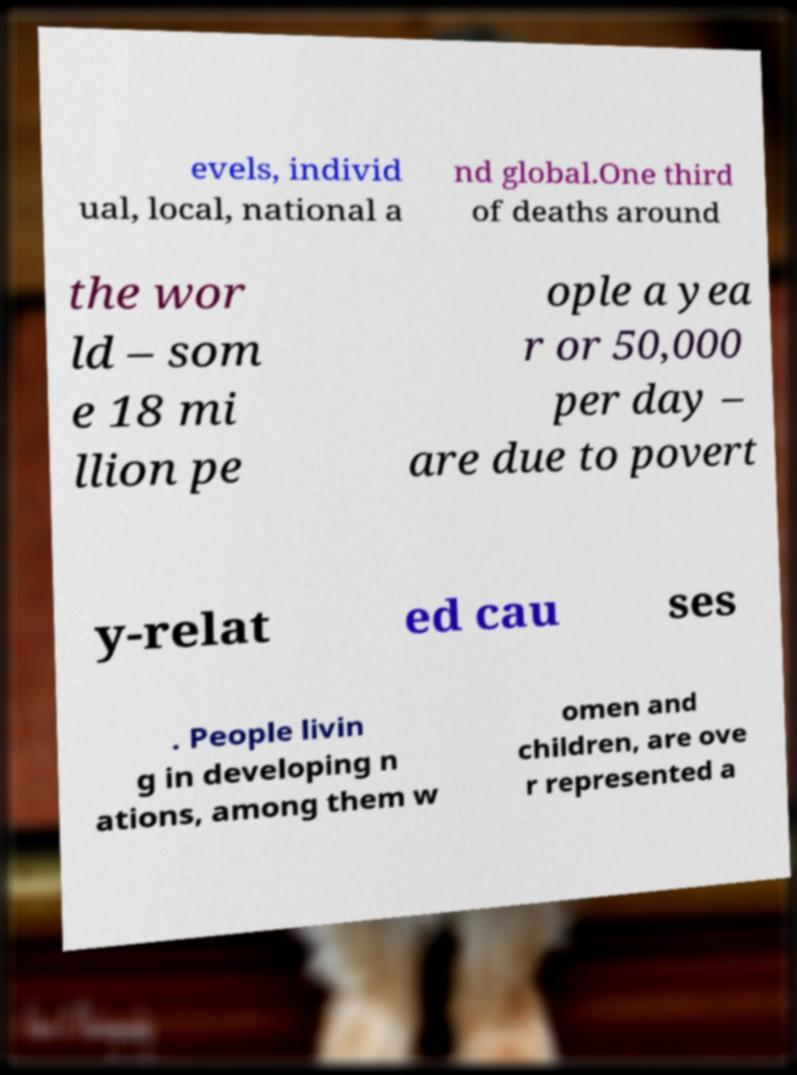Please read and relay the text visible in this image. What does it say? evels, individ ual, local, national a nd global.One third of deaths around the wor ld – som e 18 mi llion pe ople a yea r or 50,000 per day – are due to povert y-relat ed cau ses . People livin g in developing n ations, among them w omen and children, are ove r represented a 